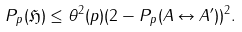Convert formula to latex. <formula><loc_0><loc_0><loc_500><loc_500>P _ { p } ( \mathfrak { H } ) \leq \theta ^ { 2 } ( p ) ( 2 - P _ { p } ( A \leftrightarrow A ^ { \prime } ) ) ^ { 2 } .</formula> 